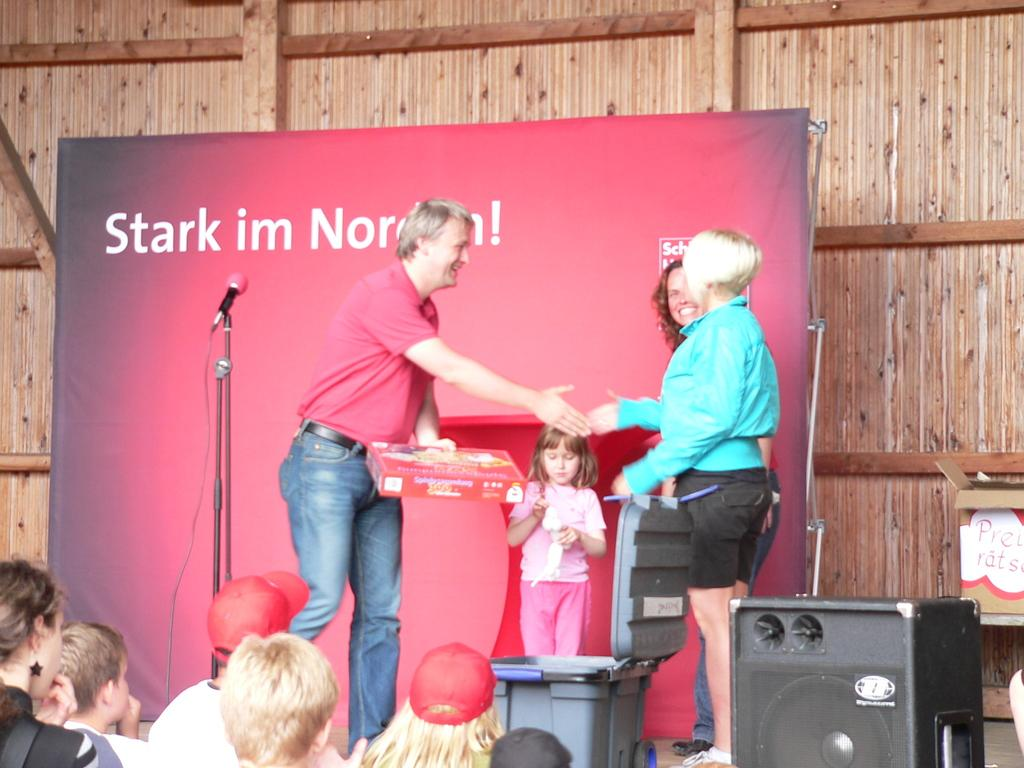How many people are in the image? There are people in the image, but the exact number is not specified. What can be seen hanging in the image? There is a banner in the image. What device is used for amplifying sound in the image? There is a mic in the image. What object is used for collecting waste in the image? There is a dustbin in the image. What object is used for playing music in the image? There is a sound box in the image. What is a person holding in his hand in the image? A person is holding a box in his hand. What type of property is being sold in the image? There is no indication of any property being sold in the image. Is it raining in the image? The facts provided do not mention anything about the weather, so we cannot determine if it is raining in the image. 